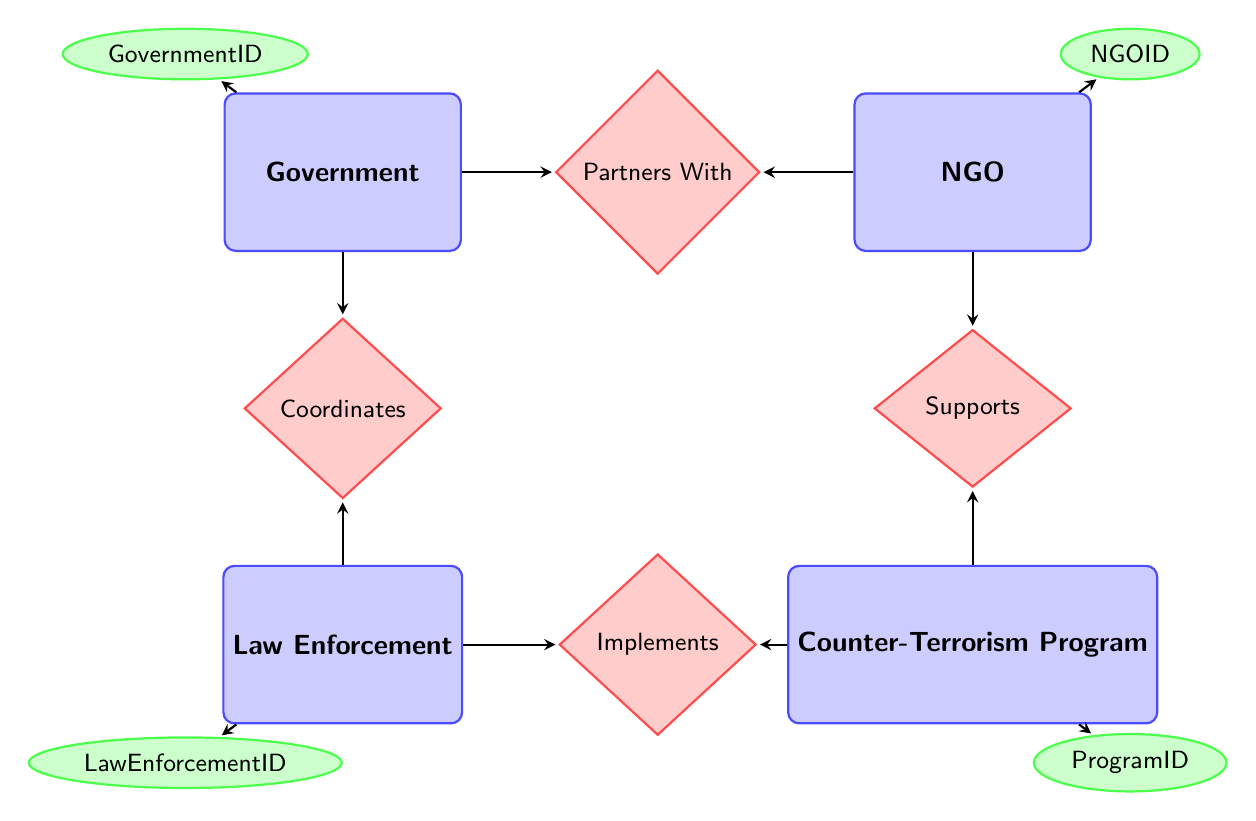What are the entities in the diagram? The diagram includes four entities: Government, NGO, Law Enforcement, and Counter-Terrorism Program, which can be read directly from the diagram as labeled nodes.
Answer: Government, NGO, Law Enforcement, Counter-Terrorism Program How many relationships are present in the diagram? There are four relationships: Coordinates, Partners With, Supports, and Implements, which can be counted by looking at the connections (diamonds) between the entities.
Answer: Four What is the focus area of the NGO? The attribute "FocusArea" of the NGO entity describes what the NGO primarily focuses on, as indicated by the attributes listed for that entity in the diagram.
Answer: FocusArea What is the support type in the relationship between NGO and Counter-Terrorism Program? The relationship "Supports" specifies the attribute "SupportType," which indicates the kind of support provided by the NGO to the Counter-Terrorism Program.
Answer: SupportType How does the Government interact with Law Enforcement? The interaction is defined by the relationship "Coordinates," which illustrates how the Government works with Law Enforcement, denoted in the diagram.
Answer: Coordinates What is the role of Law Enforcement in implementing the Counter-Terrorism Program? The relationship "Implements" includes an attribute called "Role," which explains the specific duties or responsibilities that Law Enforcement has in this context.
Answer: Role What can be inferred from the relationship Partners With? The diagram shows that the Government has a partnership with NGOs which includes both the "PartnershipPurpose" and "PartnershipDuration," indicating the nature and time frame of their collaboration.
Answer: PartnershipPurpose, PartnershipDuration How many attributes does the Government entity have? The Government entity has three attributes listed: GovernmentID, Name, and Jurisdiction, which can be verified by examining the attribute ellipses connected to the Government entity.
Answer: Three Which entities are involved in the Supports relationship? The Supports relationship involves two entities: NGO and Counter-Terrorism Program, which can be identified from the corresponding line connecting these entities to the "Supports" diamond.
Answer: NGO, Counter-Terrorism Program 